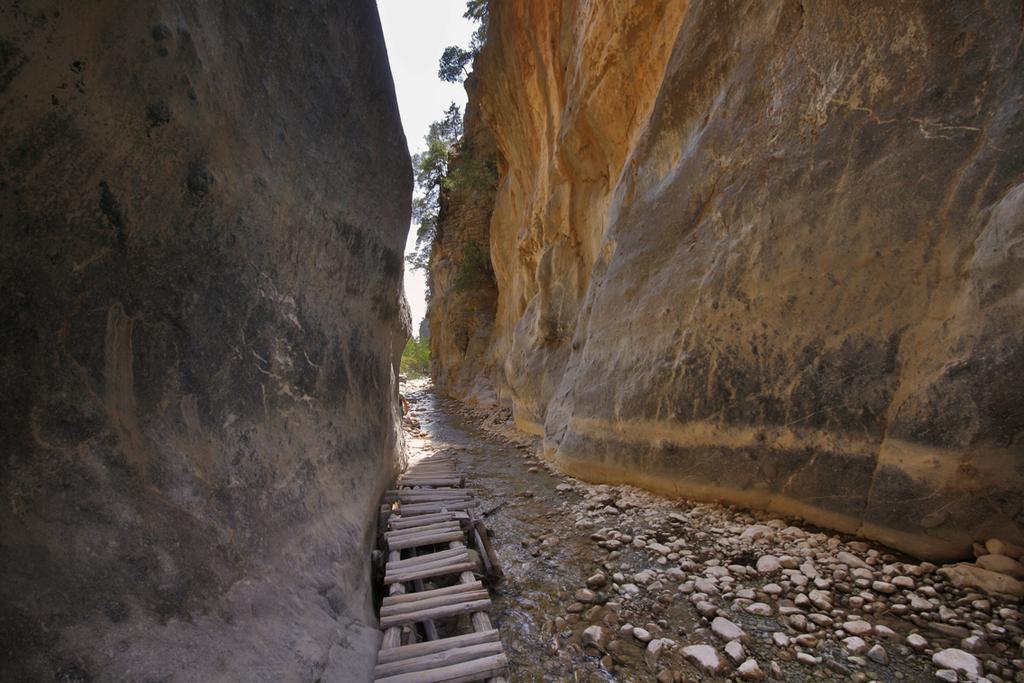Can you describe this image briefly? In this image we can see hills, ladder, stones, trees and sky. 